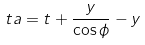Convert formula to latex. <formula><loc_0><loc_0><loc_500><loc_500>\ t a = t + \frac { y } { \cos \phi } - y</formula> 